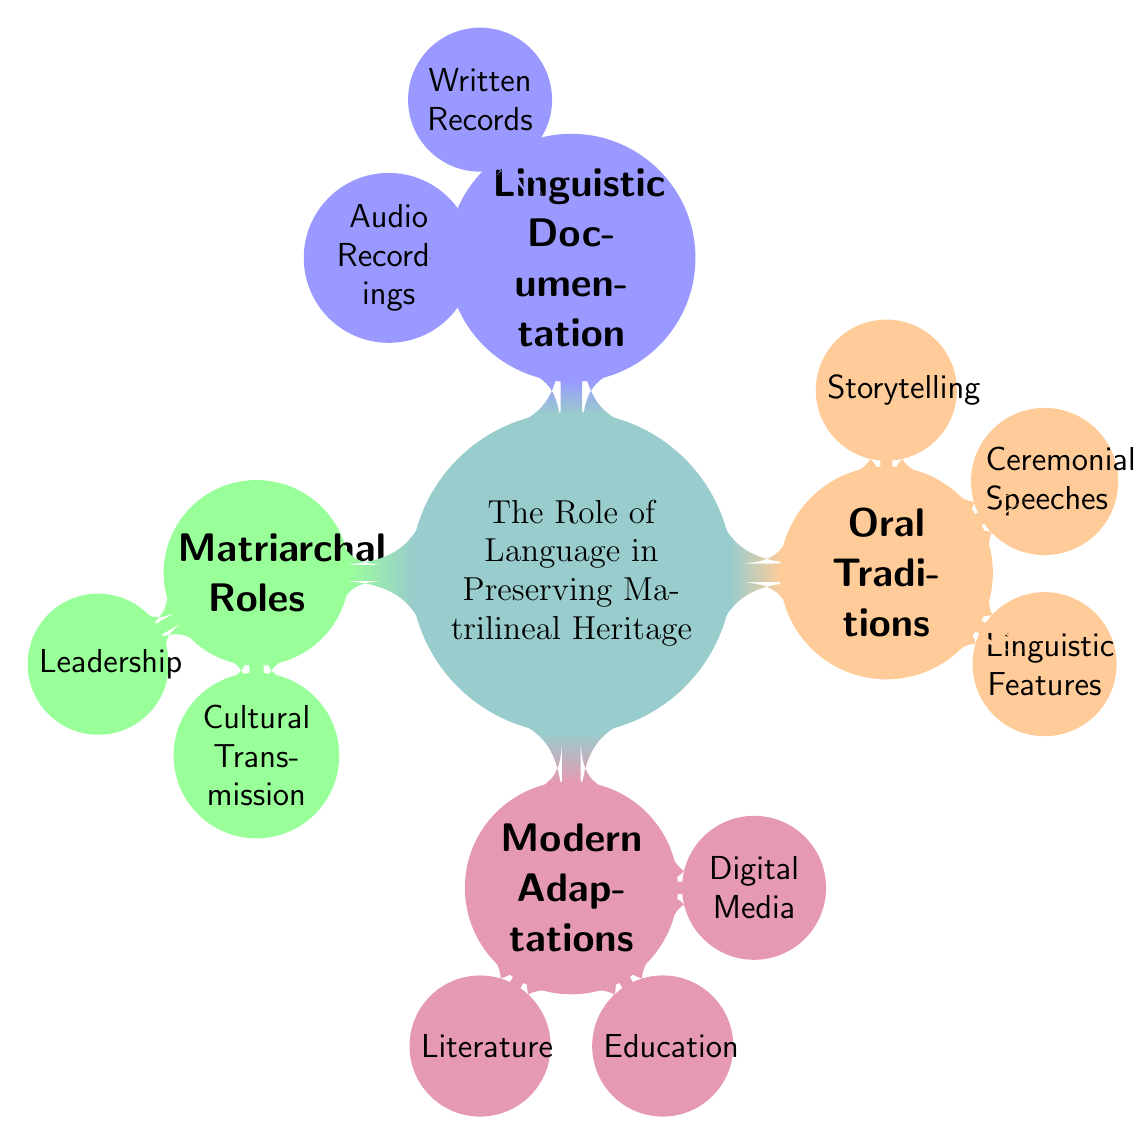What is the main topic of the mind map? The main topic is explicitly stated at the center of the diagram, labeled "The Role of Language in Preserving Matrilineal Heritage: Oral Traditions and Modern Adaptations."
Answer: The Role of Language in Preserving Matrilineal Heritage: Oral Traditions and Modern Adaptations How many primary nodes are in the diagram? By counting the main branches emerging from the central concept, we find four primary nodes: Oral Traditions, Modern Adaptations, Matriarchal Roles, and Linguistic Documentation.
Answer: Four What are the three subcategories under Modern Adaptations? Under the Modern Adaptations node, there are three subcategories listed: Digital Media, Education, and Literature.
Answer: Digital Media, Education, Literature Which node discusses the role of female community members? The node titled "Matriarchal Roles" pertains to the roles of female community members in cultural contexts.
Answer: Matriarchal Roles What type of linguistic elements are highlighted under Oral Traditions? The three highlighted elements related to Oral Traditions are Storytelling, Ceremonial Speeches, and Linguistic Features.
Answer: Storytelling, Ceremonial Speeches, Linguistic Features What forms of documentation are mentioned under Linguistic Documentation? The documentation types specified under Linguistic Documentation include Audio Recordings and Written Records.
Answer: Audio Recordings, Written Records How are the subcategories under Oral Traditions connected to storytelling? Within the Oral Traditions node, Storytelling is directly linked as one of its three subcategories, indicating a specific area of focus for cultural expression through language.
Answer: Storytelling Which node describes the transmission of culture by maternal figures? The node "Cultural Transmission" under Matriarchal Roles addresses the specific transmission of culture by maternal figures.
Answer: Cultural Transmission 